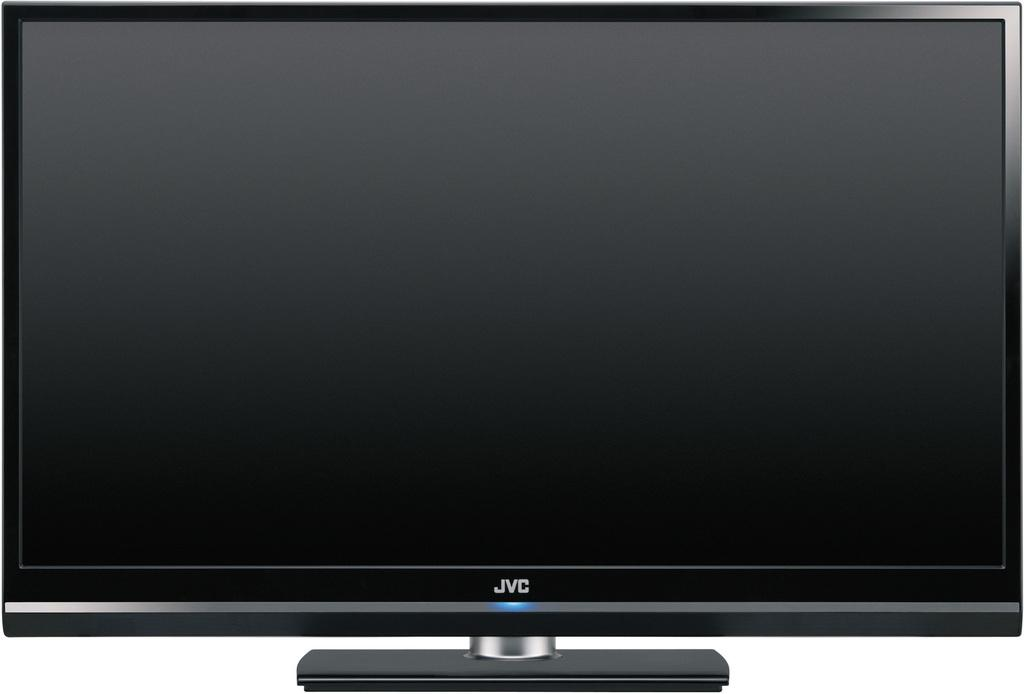Provide a one-sentence caption for the provided image. A thin black JVC flat screen is being shown in the picture. 